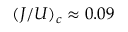<formula> <loc_0><loc_0><loc_500><loc_500>( J / U ) _ { c } \approx 0 . 0 9</formula> 